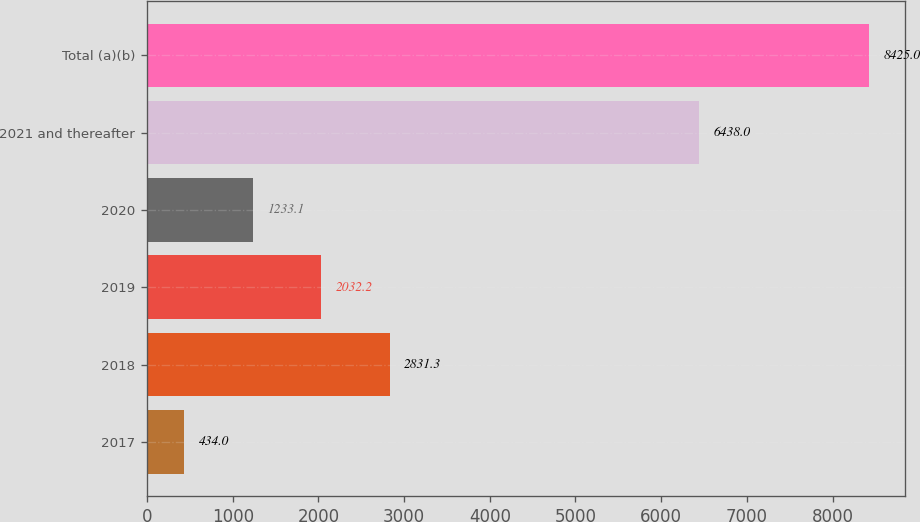Convert chart. <chart><loc_0><loc_0><loc_500><loc_500><bar_chart><fcel>2017<fcel>2018<fcel>2019<fcel>2020<fcel>2021 and thereafter<fcel>Total (a)(b)<nl><fcel>434<fcel>2831.3<fcel>2032.2<fcel>1233.1<fcel>6438<fcel>8425<nl></chart> 